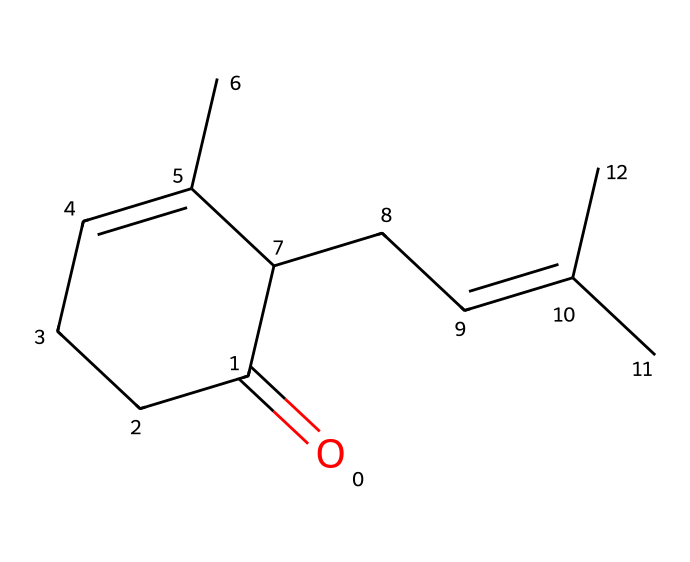What is the molecular formula of jasmone? To determine the molecular formula, you need to count the number of each type of atom in the SMILES representation. The structure includes 15 carbons, 24 hydrogens, and 1 oxygen. Therefore, the molecular formula is C15H24O.
Answer: C15H24O How many rings are present in jasmone's structure? In the SMILES representation, the numbers indicate where rings are formed. The '1' after the carbon atoms shows that the structure contains one ring, so there is one ring present in jasmone.
Answer: 1 What is the functional group present in jasmone? A ketone has a carbonyl group (C=O). In the SMILES representation, the 'O=' indicates the presence of a carbonyl, confirming that jasmone contains the ketone functional group.
Answer: ketone How many double bonds are in jasmone's structure? The presence of '=' in the SMILES indicates double bonds between specific carbon atoms. Counting these '=' symbols confirms there are two double bonds in the structure of jasmone.
Answer: 2 What is jasmone primarily known for? Jasmone is primarily known for its floral scent, which is reminiscent of jasmine. This characteristic makes it significant in aromatherapy and perfumery.
Answer: floral scent What type of isomerism might jasmone exhibit? Jasmone contains multiple carbon-carbon double bonds and could exhibit geometric (cis/trans) isomerism due to its structure, where the positioning of substituents can vary around these double bonds.
Answer: geometric isomerism 